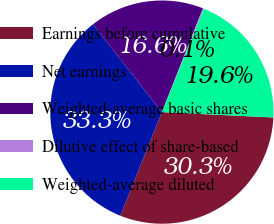Convert chart to OTSL. <chart><loc_0><loc_0><loc_500><loc_500><pie_chart><fcel>Earnings before cumulative<fcel>Net earnings<fcel>Weighted-average basic shares<fcel>Dilutive effect of share-based<fcel>Weighted-average diluted<nl><fcel>30.31%<fcel>33.33%<fcel>16.6%<fcel>0.14%<fcel>19.62%<nl></chart> 